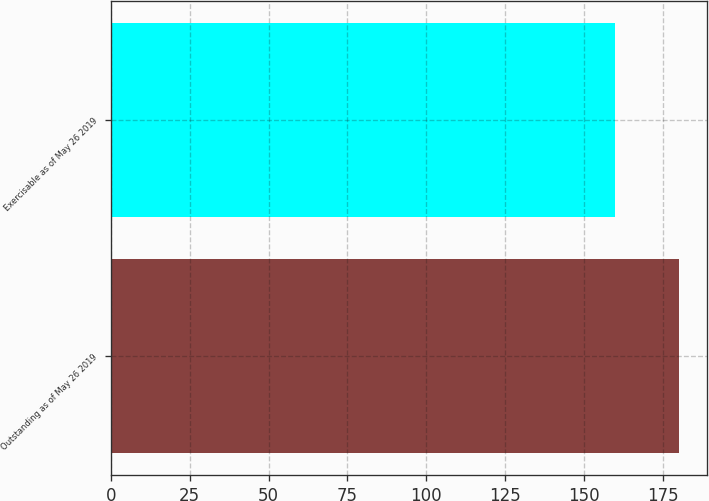<chart> <loc_0><loc_0><loc_500><loc_500><bar_chart><fcel>Outstanding as of May 26 2019<fcel>Exercisable as of May 26 2019<nl><fcel>180<fcel>159.8<nl></chart> 